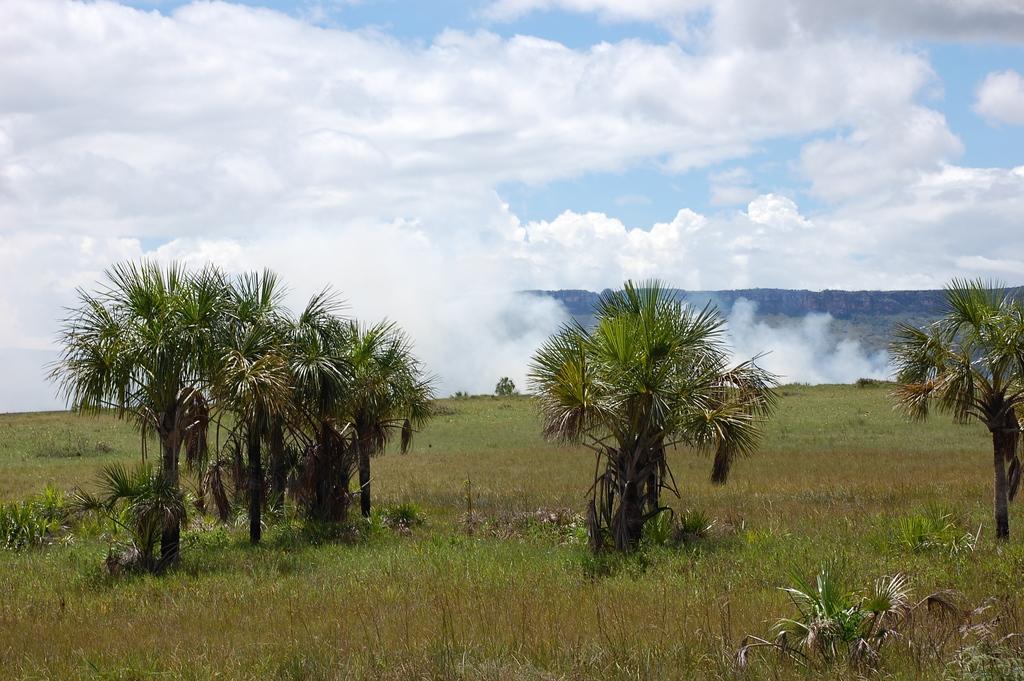Please provide a concise description of this image. In this image we can see many trees, there is grass, there is smoke, there are mountains, the sky is cloudy. 